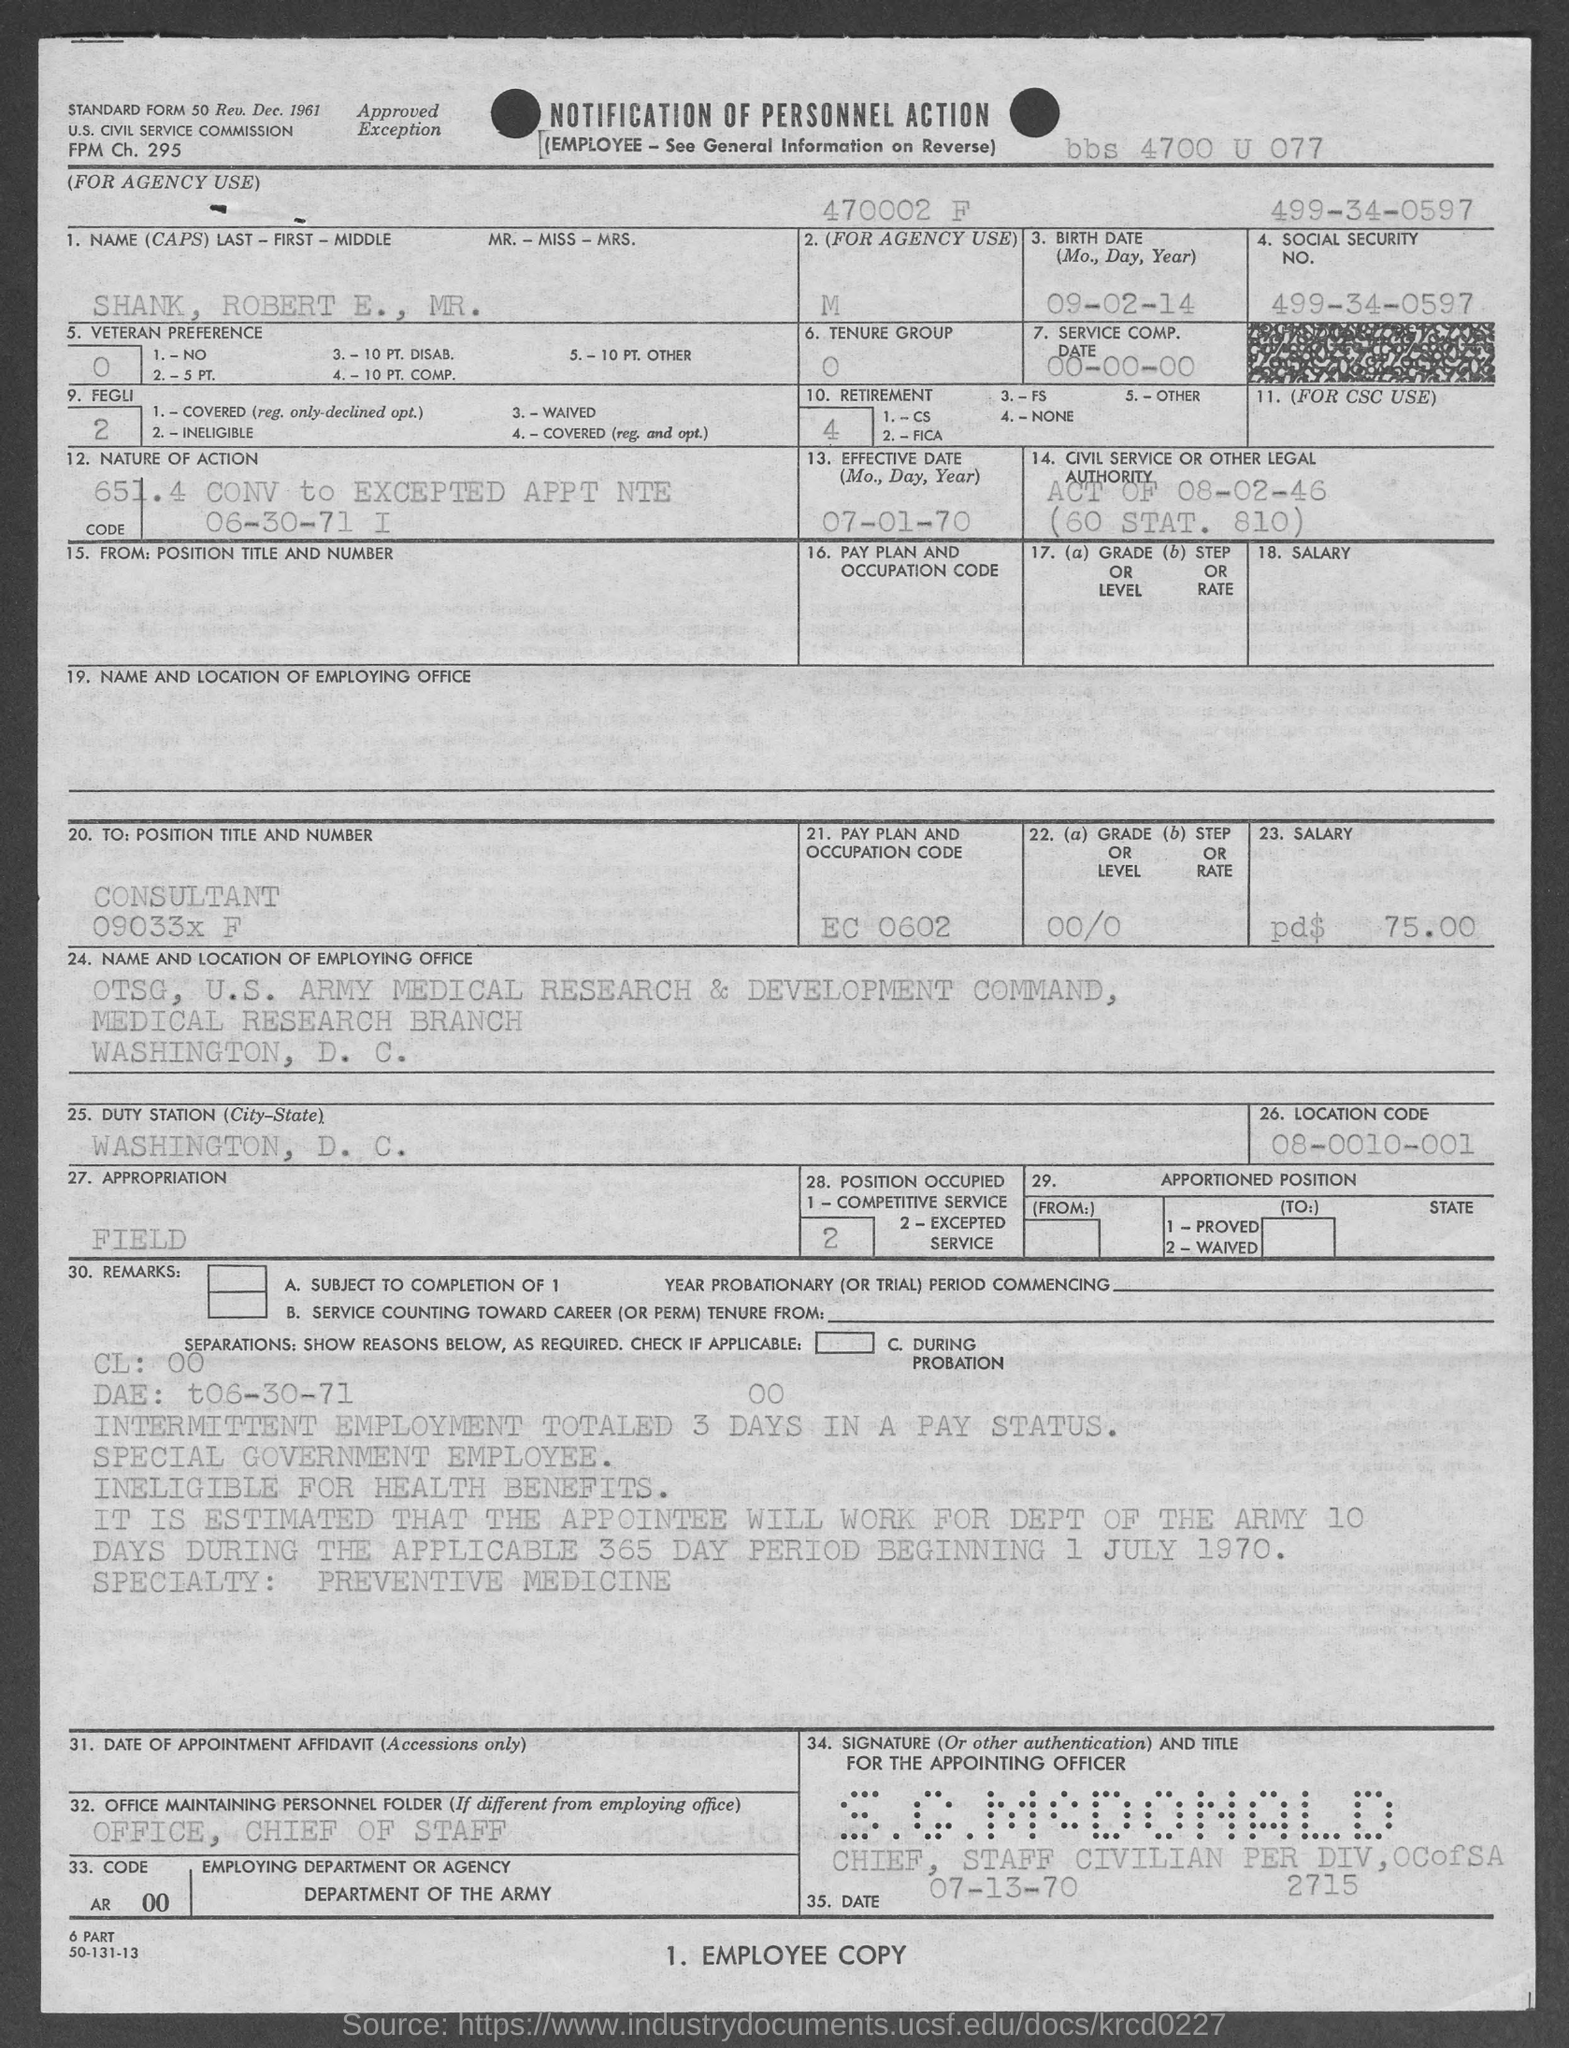Identify some key points in this picture. The Social Security Number provided in the form is 499-34-0597. The duty station of Mr. Robert E. Shank is Washington, D.C. as indicated in the form. The Service Composition Date mentioned in the form is 00-00-00. The standard form number given in the document is 50.. The location code given in the form is 08-0010-001. 